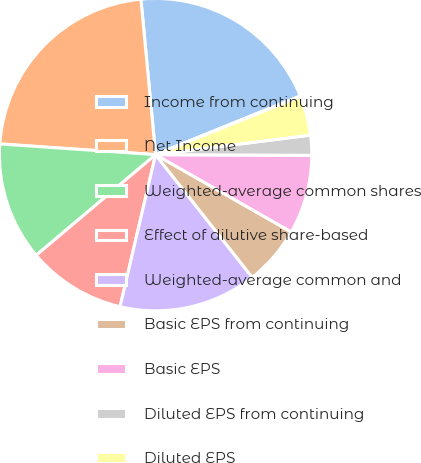Convert chart. <chart><loc_0><loc_0><loc_500><loc_500><pie_chart><fcel>Income from continuing<fcel>Net Income<fcel>Weighted-average common shares<fcel>Effect of dilutive share-based<fcel>Weighted-average common and<fcel>Basic EPS from continuing<fcel>Basic EPS<fcel>Diluted EPS from continuing<fcel>Diluted EPS<fcel>Unexercised employee stock<nl><fcel>20.37%<fcel>22.41%<fcel>12.24%<fcel>10.2%<fcel>14.27%<fcel>6.14%<fcel>8.17%<fcel>2.07%<fcel>4.1%<fcel>0.03%<nl></chart> 